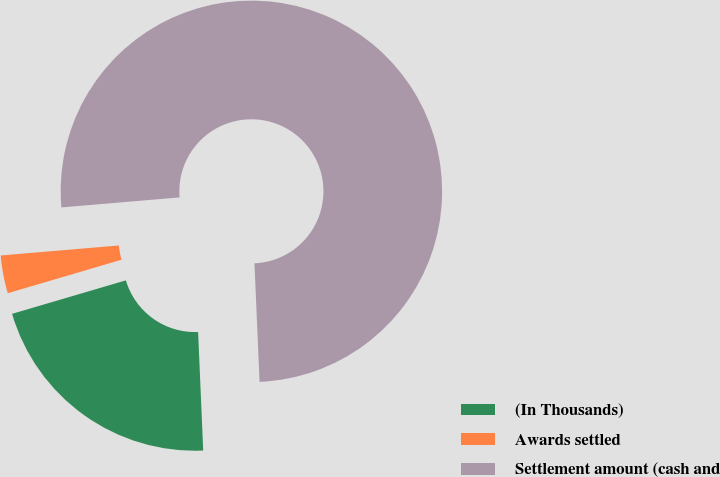Convert chart. <chart><loc_0><loc_0><loc_500><loc_500><pie_chart><fcel>(In Thousands)<fcel>Awards settled<fcel>Settlement amount (cash and<nl><fcel>21.13%<fcel>3.21%<fcel>75.66%<nl></chart> 